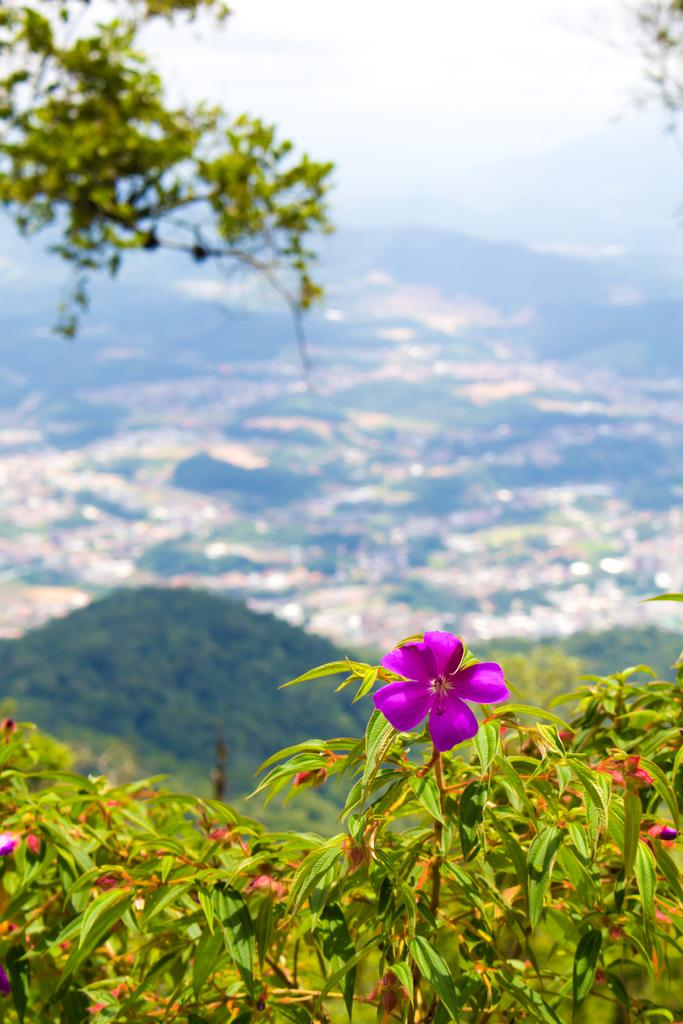What type of living organisms can be seen in the image? Plants and trees are visible in the image. What color are the flowers on the plants? The flowers on the plants are pink in color. What can be seen in the background of the image? Trees and the sky are visible in the background of the image. What part of the natural environment is visible in the image? The ground and the sky are visible in the image. What type of machine can be seen operating on the floor in the image? There is no machine present on the floor in the image; it features plants with pink flowers, trees, and the sky in the background. Is there a ghost visible in the image? There is no ghost present in the image. 